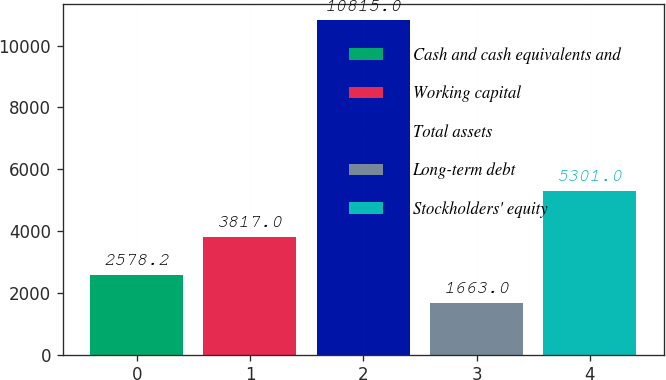Convert chart to OTSL. <chart><loc_0><loc_0><loc_500><loc_500><bar_chart><fcel>Cash and cash equivalents and<fcel>Working capital<fcel>Total assets<fcel>Long-term debt<fcel>Stockholders' equity<nl><fcel>2578.2<fcel>3817<fcel>10815<fcel>1663<fcel>5301<nl></chart> 